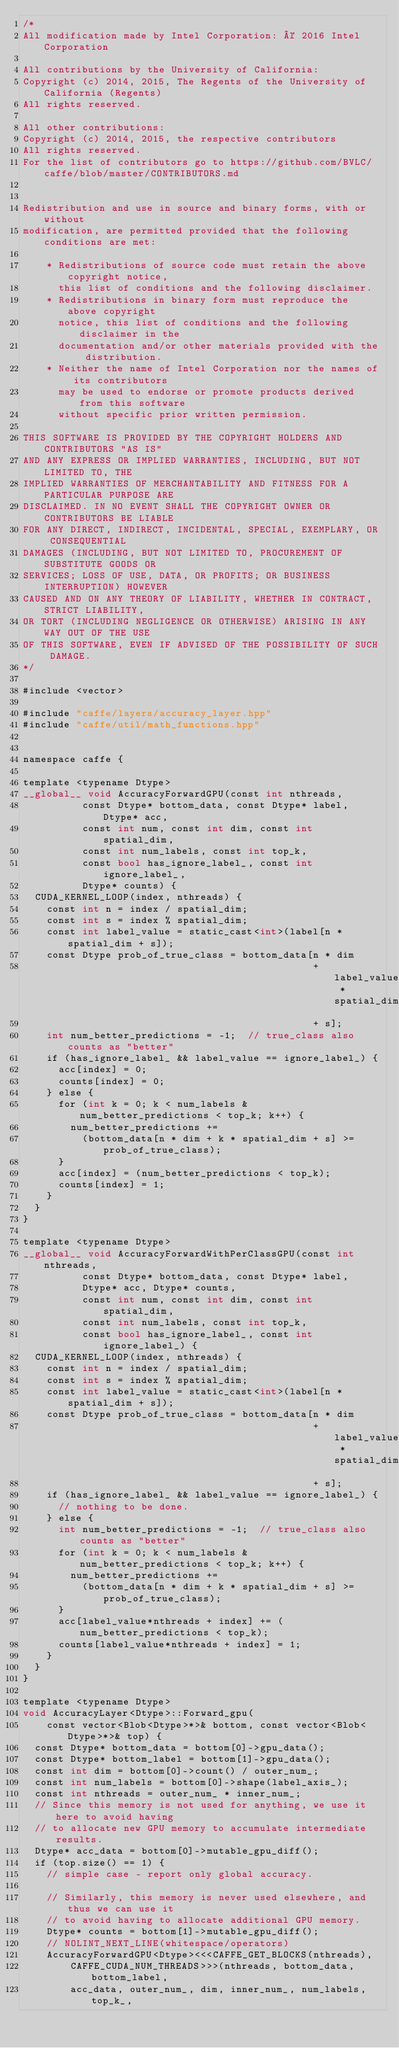Convert code to text. <code><loc_0><loc_0><loc_500><loc_500><_Cuda_>/*
All modification made by Intel Corporation: © 2016 Intel Corporation

All contributions by the University of California:
Copyright (c) 2014, 2015, The Regents of the University of California (Regents)
All rights reserved.

All other contributions:
Copyright (c) 2014, 2015, the respective contributors
All rights reserved.
For the list of contributors go to https://github.com/BVLC/caffe/blob/master/CONTRIBUTORS.md


Redistribution and use in source and binary forms, with or without
modification, are permitted provided that the following conditions are met:

    * Redistributions of source code must retain the above copyright notice,
      this list of conditions and the following disclaimer.
    * Redistributions in binary form must reproduce the above copyright
      notice, this list of conditions and the following disclaimer in the
      documentation and/or other materials provided with the distribution.
    * Neither the name of Intel Corporation nor the names of its contributors
      may be used to endorse or promote products derived from this software
      without specific prior written permission.

THIS SOFTWARE IS PROVIDED BY THE COPYRIGHT HOLDERS AND CONTRIBUTORS "AS IS"
AND ANY EXPRESS OR IMPLIED WARRANTIES, INCLUDING, BUT NOT LIMITED TO, THE
IMPLIED WARRANTIES OF MERCHANTABILITY AND FITNESS FOR A PARTICULAR PURPOSE ARE
DISCLAIMED. IN NO EVENT SHALL THE COPYRIGHT OWNER OR CONTRIBUTORS BE LIABLE
FOR ANY DIRECT, INDIRECT, INCIDENTAL, SPECIAL, EXEMPLARY, OR CONSEQUENTIAL
DAMAGES (INCLUDING, BUT NOT LIMITED TO, PROCUREMENT OF SUBSTITUTE GOODS OR
SERVICES; LOSS OF USE, DATA, OR PROFITS; OR BUSINESS INTERRUPTION) HOWEVER
CAUSED AND ON ANY THEORY OF LIABILITY, WHETHER IN CONTRACT, STRICT LIABILITY,
OR TORT (INCLUDING NEGLIGENCE OR OTHERWISE) ARISING IN ANY WAY OUT OF THE USE
OF THIS SOFTWARE, EVEN IF ADVISED OF THE POSSIBILITY OF SUCH DAMAGE.
*/

#include <vector>

#include "caffe/layers/accuracy_layer.hpp"
#include "caffe/util/math_functions.hpp"


namespace caffe {

template <typename Dtype>
__global__ void AccuracyForwardGPU(const int nthreads,
          const Dtype* bottom_data, const Dtype* label, Dtype* acc,
          const int num, const int dim, const int spatial_dim,
          const int num_labels, const int top_k,
          const bool has_ignore_label_, const int ignore_label_,
          Dtype* counts) {
  CUDA_KERNEL_LOOP(index, nthreads) {
    const int n = index / spatial_dim;
    const int s = index % spatial_dim;
    const int label_value = static_cast<int>(label[n * spatial_dim + s]);
    const Dtype prob_of_true_class = bottom_data[n * dim
                                                 + label_value * spatial_dim
                                                 + s];
    int num_better_predictions = -1;  // true_class also counts as "better"
    if (has_ignore_label_ && label_value == ignore_label_) {
      acc[index] = 0;
      counts[index] = 0;
    } else {
      for (int k = 0; k < num_labels & num_better_predictions < top_k; k++) {
        num_better_predictions +=
          (bottom_data[n * dim + k * spatial_dim + s] >= prob_of_true_class);
      }
      acc[index] = (num_better_predictions < top_k);
      counts[index] = 1;
    }
  }
}

template <typename Dtype>
__global__ void AccuracyForwardWithPerClassGPU(const int nthreads,
          const Dtype* bottom_data, const Dtype* label,
          Dtype* acc, Dtype* counts,
          const int num, const int dim, const int spatial_dim,
          const int num_labels, const int top_k,
          const bool has_ignore_label_, const int ignore_label_) {
  CUDA_KERNEL_LOOP(index, nthreads) {
    const int n = index / spatial_dim;
    const int s = index % spatial_dim;
    const int label_value = static_cast<int>(label[n * spatial_dim + s]);
    const Dtype prob_of_true_class = bottom_data[n * dim
                                                 + label_value * spatial_dim
                                                 + s];
    if (has_ignore_label_ && label_value == ignore_label_) {
      // nothing to be done.
    } else {
      int num_better_predictions = -1;  // true_class also counts as "better"
      for (int k = 0; k < num_labels & num_better_predictions < top_k; k++) {
        num_better_predictions +=
          (bottom_data[n * dim + k * spatial_dim + s] >= prob_of_true_class);
      }
      acc[label_value*nthreads + index] += (num_better_predictions < top_k);
      counts[label_value*nthreads + index] = 1;
    }
  }
}

template <typename Dtype>
void AccuracyLayer<Dtype>::Forward_gpu(
    const vector<Blob<Dtype>*>& bottom, const vector<Blob<Dtype>*>& top) {
  const Dtype* bottom_data = bottom[0]->gpu_data();
  const Dtype* bottom_label = bottom[1]->gpu_data();
  const int dim = bottom[0]->count() / outer_num_;
  const int num_labels = bottom[0]->shape(label_axis_);
  const int nthreads = outer_num_ * inner_num_;
  // Since this memory is not used for anything, we use it here to avoid having
  // to allocate new GPU memory to accumulate intermediate results.
  Dtype* acc_data = bottom[0]->mutable_gpu_diff();
  if (top.size() == 1) {
    // simple case - report only global accuracy.

    // Similarly, this memory is never used elsewhere, and thus we can use it
    // to avoid having to allocate additional GPU memory.
    Dtype* counts = bottom[1]->mutable_gpu_diff();
    // NOLINT_NEXT_LINE(whitespace/operators)
    AccuracyForwardGPU<Dtype><<<CAFFE_GET_BLOCKS(nthreads),
        CAFFE_CUDA_NUM_THREADS>>>(nthreads, bottom_data, bottom_label,
        acc_data, outer_num_, dim, inner_num_, num_labels, top_k_,</code> 